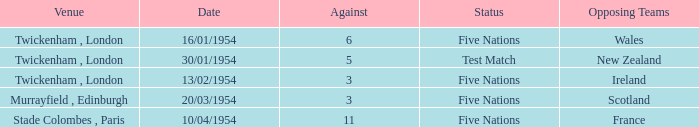What was the venue for the game played on 13/02/1954? Twickenham , London. 